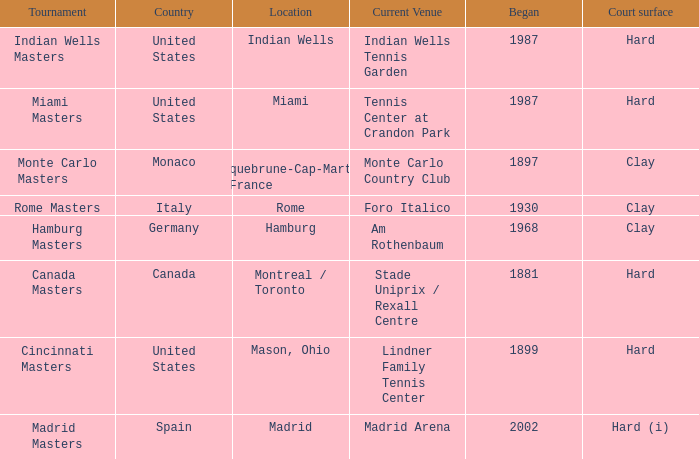Parse the table in full. {'header': ['Tournament', 'Country', 'Location', 'Current Venue', 'Began', 'Court surface'], 'rows': [['Indian Wells Masters', 'United States', 'Indian Wells', 'Indian Wells Tennis Garden', '1987', 'Hard'], ['Miami Masters', 'United States', 'Miami', 'Tennis Center at Crandon Park', '1987', 'Hard'], ['Monte Carlo Masters', 'Monaco', 'Roquebrune-Cap-Martin , France', 'Monte Carlo Country Club', '1897', 'Clay'], ['Rome Masters', 'Italy', 'Rome', 'Foro Italico', '1930', 'Clay'], ['Hamburg Masters', 'Germany', 'Hamburg', 'Am Rothenbaum', '1968', 'Clay'], ['Canada Masters', 'Canada', 'Montreal / Toronto', 'Stade Uniprix / Rexall Centre', '1881', 'Hard'], ['Cincinnati Masters', 'United States', 'Mason, Ohio', 'Lindner Family Tennis Center', '1899', 'Hard'], ['Madrid Masters', 'Spain', 'Madrid', 'Madrid Arena', '2002', 'Hard (i)']]} At which venue is the miami masters tournament currently held? Tennis Center at Crandon Park. 